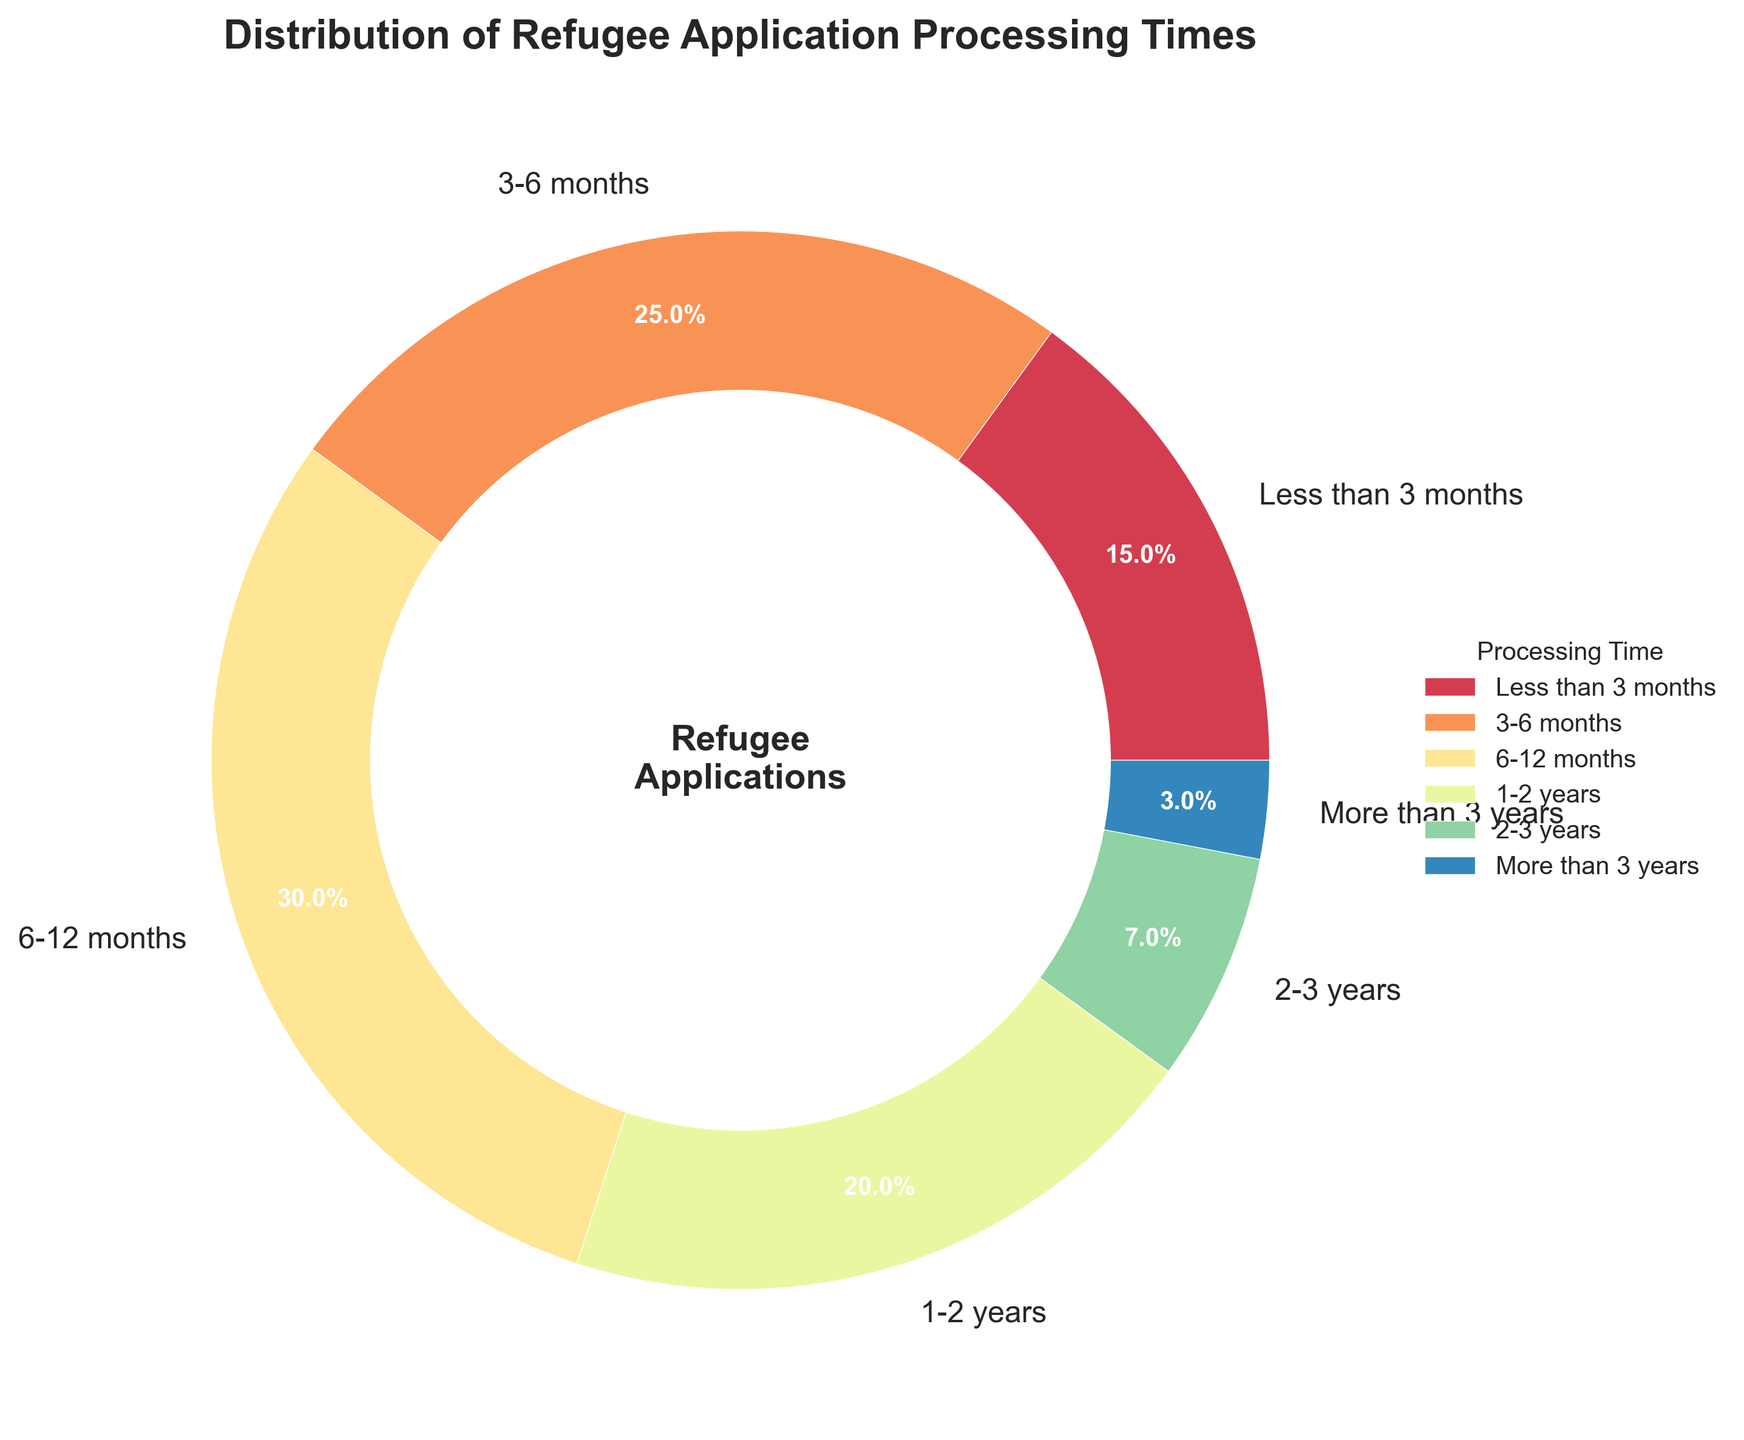How much does the combined percentage of applications processed within 3-12 months represent? To find the combined percentage, sum the percentages for processing times 'Less than 3 months', '3-6 months', and '6-12 months': 15% + 25% + 30% = 70%
Answer: 70% Which processing time category has the highest percentage? By looking at the size of each section and the percentage labels in the pie chart, the '6-12 months' category has the highest percentage of 30%
Answer: 6-12 months What is the difference between the percentages of applications processed in '6-12 months' and '2-3 years'? Subtract the percentage of '2-3 years' from '6-12 months': 30% - 7% = 23%
Answer: 23% How many categories have a processing time of one year or more? The categories '1-2 years', '2-3 years', and 'More than 3 years' have processing times of one year or more, making a total of 3 categories
Answer: 3 Which category represents the smallest percentage of applications? By looking at the size and labels on the pie chart, the 'More than 3 years' category represents the smallest percentage of 3%
Answer: More than 3 years What are the percentages of applications processed either in '3-6 months' or '1-2 years'? Sum the given percentages for '3-6 months' and '1-2 years': 25% + 20% = 45%
Answer: 45% Compare the percentages of applications processed in less than a year to those processed in a year or more. Which is greater and by how much? Sum the percentages of applications processed in less than a year (15% + 25% + 30% = 70%) and those processed in a year or more (20% + 7% + 3% = 30%). The percentage in less than a year is greater: 70% - 30% = 40%
Answer: Less than a year, by 40% Identify the slice of the chart with the darkest color. What category does it represent? The slice with the darkest color represents the 'More than 3 years' category, as color intensity typically decreases with smaller percentages in a pie chart using a spectral color map
Answer: More than 3 years What logical operation can you perform to determine the exact percentage of applications not processed within a year? Describe the procedure and include the result. Add the percentages of categories with processing times of '1-2 years', '2-3 years', and 'More than 3 years': 20% + 7% + 3%. The sum represents the percentage not processed within a year: 20% + 7% + 3% = 30%
Answer: 30% 